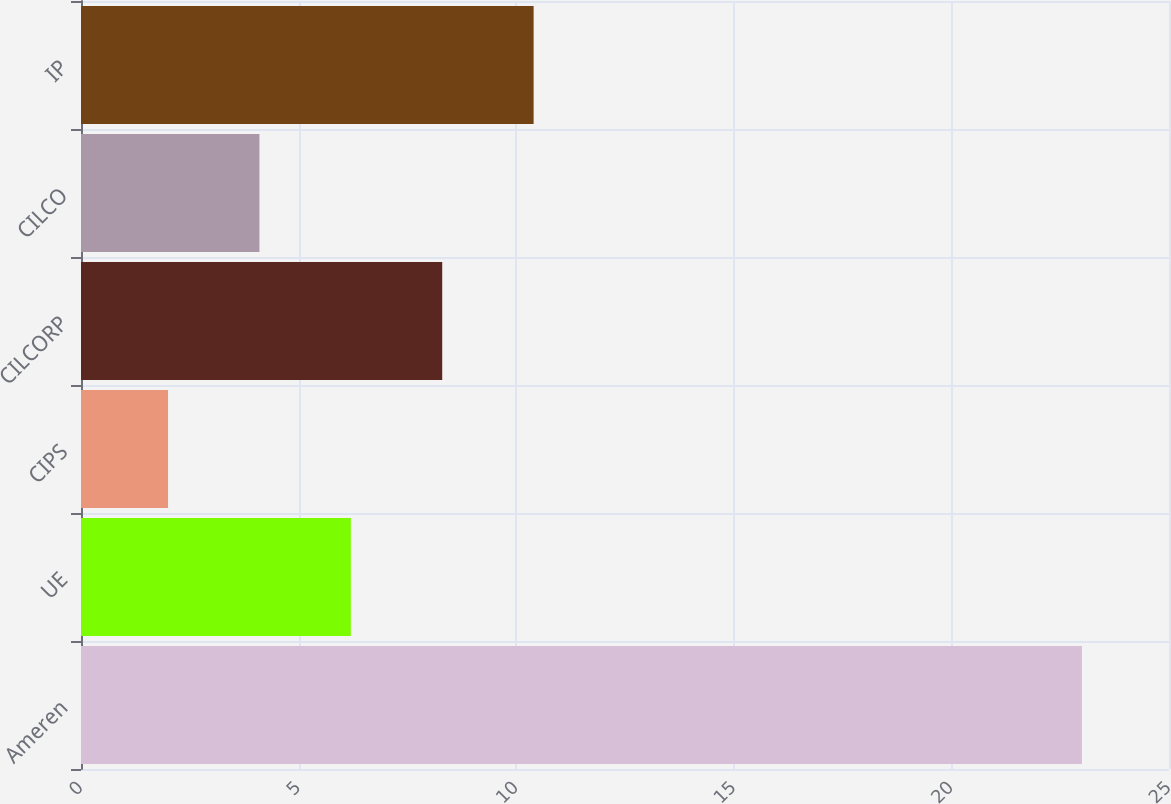<chart> <loc_0><loc_0><loc_500><loc_500><bar_chart><fcel>Ameren<fcel>UE<fcel>CIPS<fcel>CILCORP<fcel>CILCO<fcel>IP<nl><fcel>23<fcel>6.2<fcel>2<fcel>8.3<fcel>4.1<fcel>10.4<nl></chart> 